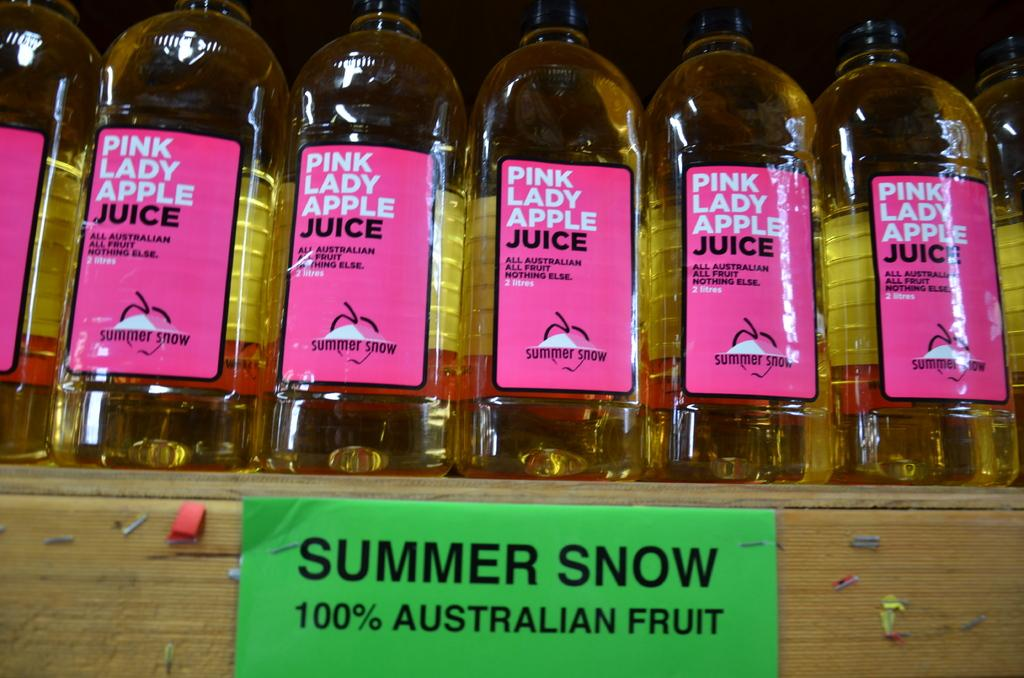<image>
Provide a brief description of the given image. Multiple bottle of Pink Lady Apple Juice on the shelf. 